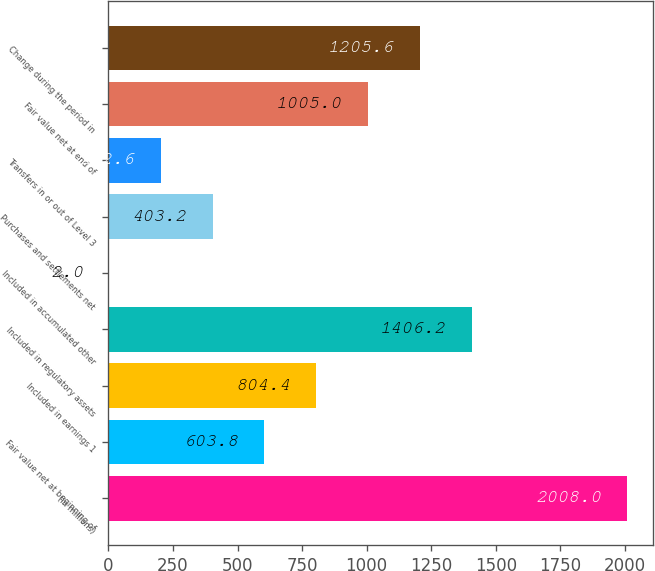Convert chart to OTSL. <chart><loc_0><loc_0><loc_500><loc_500><bar_chart><fcel>(in millions)<fcel>Fair value net at beginning of<fcel>Included in earnings 1<fcel>Included in regulatory assets<fcel>Included in accumulated other<fcel>Purchases and settlements net<fcel>Transfers in or out of Level 3<fcel>Fair value net at end of<fcel>Change during the period in<nl><fcel>2008<fcel>603.8<fcel>804.4<fcel>1406.2<fcel>2<fcel>403.2<fcel>202.6<fcel>1005<fcel>1205.6<nl></chart> 